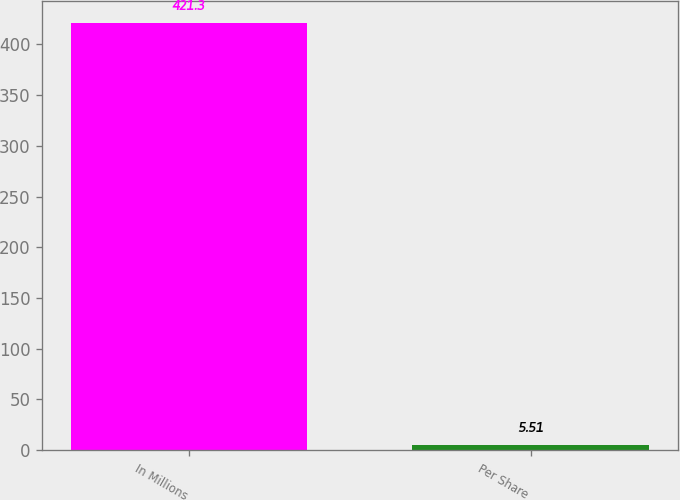Convert chart. <chart><loc_0><loc_0><loc_500><loc_500><bar_chart><fcel>In Millions<fcel>Per Share<nl><fcel>421.3<fcel>5.51<nl></chart> 